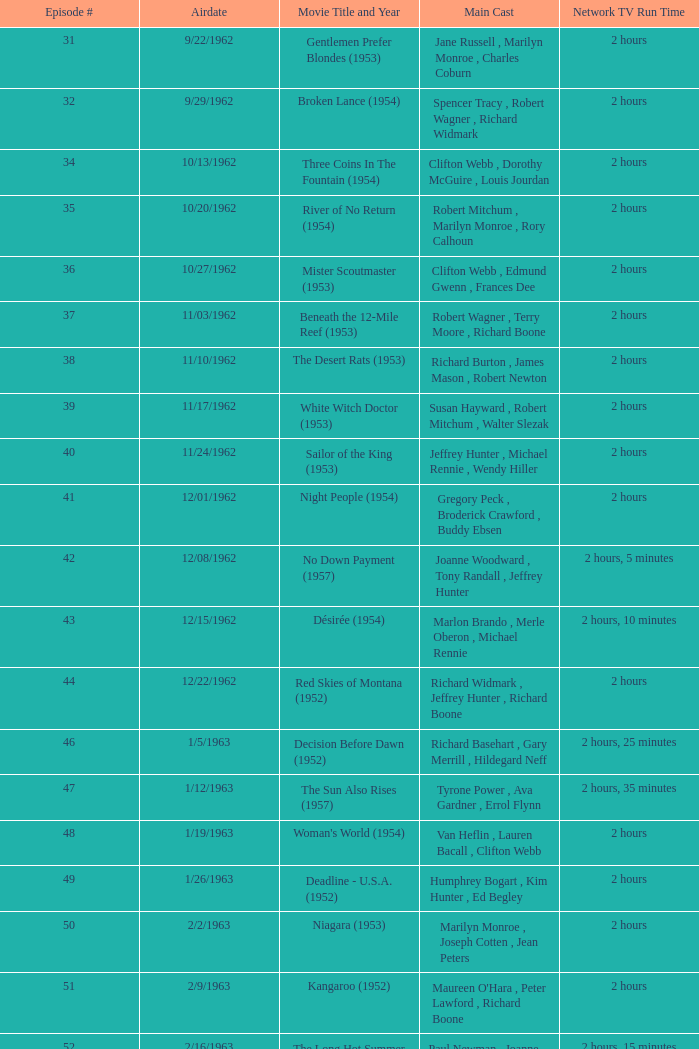Give me the full table as a dictionary. {'header': ['Episode #', 'Airdate', 'Movie Title and Year', 'Main Cast', 'Network TV Run Time'], 'rows': [['31', '9/22/1962', 'Gentlemen Prefer Blondes (1953)', 'Jane Russell , Marilyn Monroe , Charles Coburn', '2 hours'], ['32', '9/29/1962', 'Broken Lance (1954)', 'Spencer Tracy , Robert Wagner , Richard Widmark', '2 hours'], ['34', '10/13/1962', 'Three Coins In The Fountain (1954)', 'Clifton Webb , Dorothy McGuire , Louis Jourdan', '2 hours'], ['35', '10/20/1962', 'River of No Return (1954)', 'Robert Mitchum , Marilyn Monroe , Rory Calhoun', '2 hours'], ['36', '10/27/1962', 'Mister Scoutmaster (1953)', 'Clifton Webb , Edmund Gwenn , Frances Dee', '2 hours'], ['37', '11/03/1962', 'Beneath the 12-Mile Reef (1953)', 'Robert Wagner , Terry Moore , Richard Boone', '2 hours'], ['38', '11/10/1962', 'The Desert Rats (1953)', 'Richard Burton , James Mason , Robert Newton', '2 hours'], ['39', '11/17/1962', 'White Witch Doctor (1953)', 'Susan Hayward , Robert Mitchum , Walter Slezak', '2 hours'], ['40', '11/24/1962', 'Sailor of the King (1953)', 'Jeffrey Hunter , Michael Rennie , Wendy Hiller', '2 hours'], ['41', '12/01/1962', 'Night People (1954)', 'Gregory Peck , Broderick Crawford , Buddy Ebsen', '2 hours'], ['42', '12/08/1962', 'No Down Payment (1957)', 'Joanne Woodward , Tony Randall , Jeffrey Hunter', '2 hours, 5 minutes'], ['43', '12/15/1962', 'Désirée (1954)', 'Marlon Brando , Merle Oberon , Michael Rennie', '2 hours, 10 minutes'], ['44', '12/22/1962', 'Red Skies of Montana (1952)', 'Richard Widmark , Jeffrey Hunter , Richard Boone', '2 hours'], ['46', '1/5/1963', 'Decision Before Dawn (1952)', 'Richard Basehart , Gary Merrill , Hildegard Neff', '2 hours, 25 minutes'], ['47', '1/12/1963', 'The Sun Also Rises (1957)', 'Tyrone Power , Ava Gardner , Errol Flynn', '2 hours, 35 minutes'], ['48', '1/19/1963', "Woman's World (1954)", 'Van Heflin , Lauren Bacall , Clifton Webb', '2 hours'], ['49', '1/26/1963', 'Deadline - U.S.A. (1952)', 'Humphrey Bogart , Kim Hunter , Ed Begley', '2 hours'], ['50', '2/2/1963', 'Niagara (1953)', 'Marilyn Monroe , Joseph Cotten , Jean Peters', '2 hours'], ['51', '2/9/1963', 'Kangaroo (1952)', "Maureen O'Hara , Peter Lawford , Richard Boone", '2 hours'], ['52', '2/16/1963', 'The Long Hot Summer (1958)', 'Paul Newman , Joanne Woodward , Orson Wells', '2 hours, 15 minutes'], ['53', '2/23/1963', "The President's Lady (1953)", 'Susan Hayward , Charlton Heston , John McIntire', '2 hours'], ['54', '3/2/1963', 'The Roots of Heaven (1958)', 'Errol Flynn , Juliette Greco , Eddie Albert', '2 hours, 25 minutes'], ['55', '3/9/1963', 'In Love and War (1958)', 'Robert Wagner , Hope Lange , Jeffrey Hunter', '2 hours, 10 minutes'], ['56', '3/16/1963', 'A Certain Smile (1958)', 'Rossano Brazzi , Joan Fontaine , Johnny Mathis', '2 hours, 5 minutes'], ['57', '3/23/1963', 'Fraulein (1958)', 'Dana Wynter , Mel Ferrer , Theodore Bikel', '2 hours'], ['59', '4/6/1963', 'Night and the City (1950)', 'Richard Widmark , Gene Tierney , Herbert Lom', '2 hours']]} How many runtimes does episode 53 have? 1.0. 